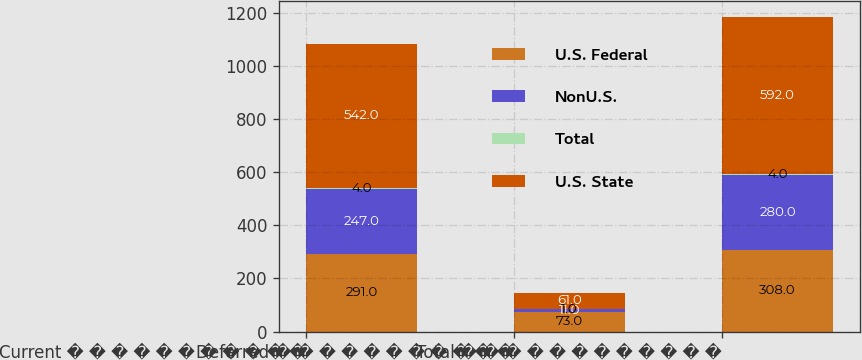Convert chart to OTSL. <chart><loc_0><loc_0><loc_500><loc_500><stacked_bar_chart><ecel><fcel>Current � � � � � � � � � � �<fcel>Deferred � � � � � � � � � � �<fcel>Total � � � � � � � � � � � �<nl><fcel>U.S. Federal<fcel>291<fcel>73<fcel>308<nl><fcel>NonU.S.<fcel>247<fcel>11<fcel>280<nl><fcel>Total<fcel>4<fcel>1<fcel>4<nl><fcel>U.S. State<fcel>542<fcel>61<fcel>592<nl></chart> 